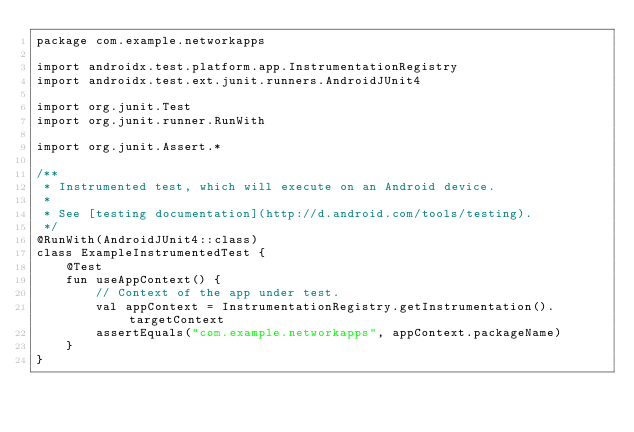<code> <loc_0><loc_0><loc_500><loc_500><_Kotlin_>package com.example.networkapps

import androidx.test.platform.app.InstrumentationRegistry
import androidx.test.ext.junit.runners.AndroidJUnit4

import org.junit.Test
import org.junit.runner.RunWith

import org.junit.Assert.*

/**
 * Instrumented test, which will execute on an Android device.
 *
 * See [testing documentation](http://d.android.com/tools/testing).
 */
@RunWith(AndroidJUnit4::class)
class ExampleInstrumentedTest {
    @Test
    fun useAppContext() {
        // Context of the app under test.
        val appContext = InstrumentationRegistry.getInstrumentation().targetContext
        assertEquals("com.example.networkapps", appContext.packageName)
    }
}
</code> 